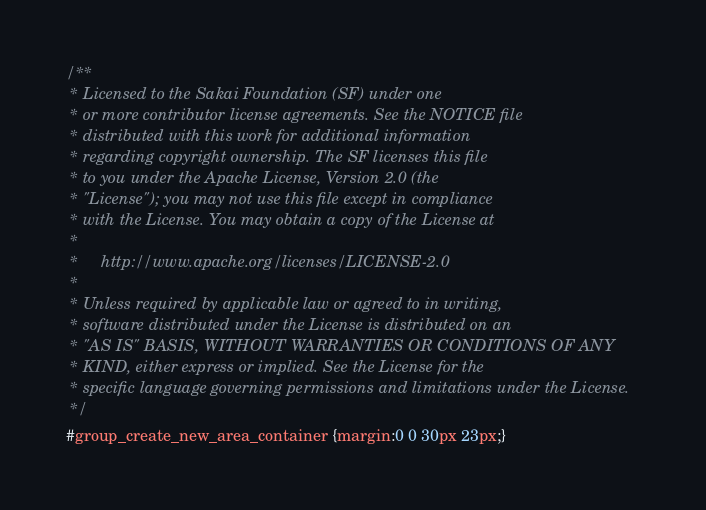<code> <loc_0><loc_0><loc_500><loc_500><_CSS_>/**
 * Licensed to the Sakai Foundation (SF) under one
 * or more contributor license agreements. See the NOTICE file
 * distributed with this work for additional information
 * regarding copyright ownership. The SF licenses this file
 * to you under the Apache License, Version 2.0 (the
 * "License"); you may not use this file except in compliance
 * with the License. You may obtain a copy of the License at
 *
 *     http://www.apache.org/licenses/LICENSE-2.0
 *
 * Unless required by applicable law or agreed to in writing,
 * software distributed under the License is distributed on an
 * "AS IS" BASIS, WITHOUT WARRANTIES OR CONDITIONS OF ANY
 * KIND, either express or implied. See the License for the
 * specific language governing permissions and limitations under the License.
 */
#group_create_new_area_container {margin:0 0 30px 23px;}</code> 